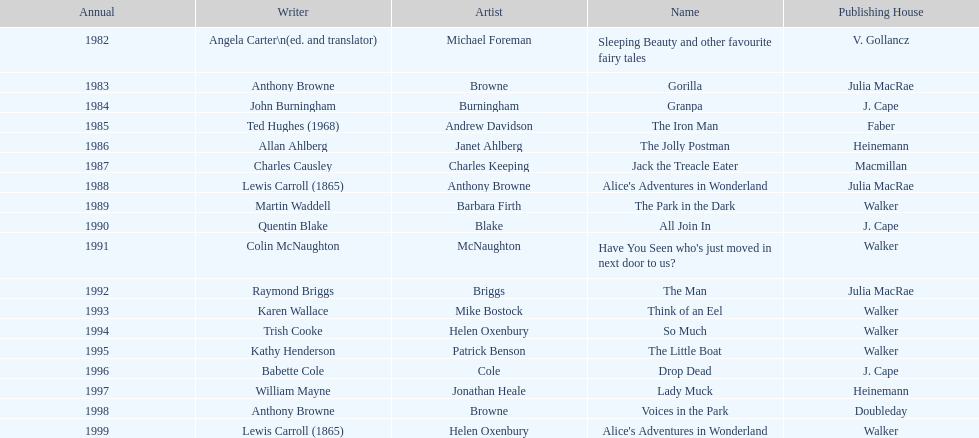How many titles had the same author listed as the illustrator? 7. 